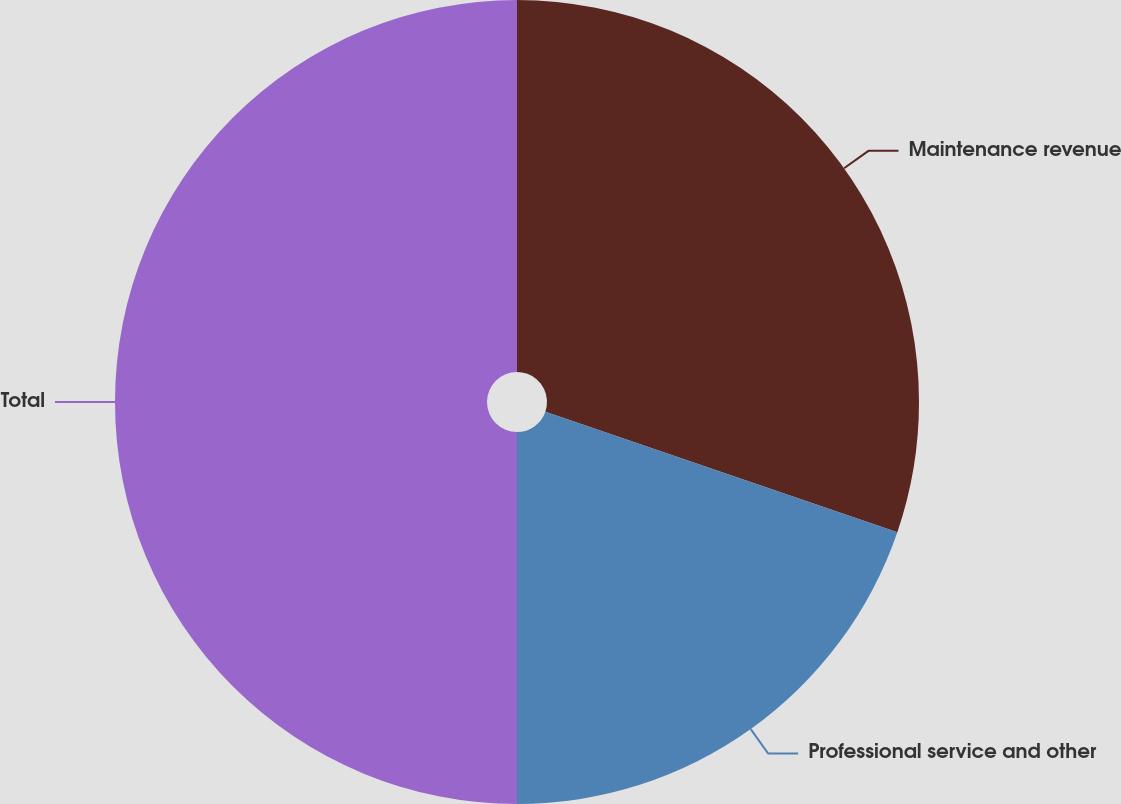Convert chart. <chart><loc_0><loc_0><loc_500><loc_500><pie_chart><fcel>Maintenance revenue<fcel>Professional service and other<fcel>Total<nl><fcel>30.25%<fcel>19.75%<fcel>50.0%<nl></chart> 